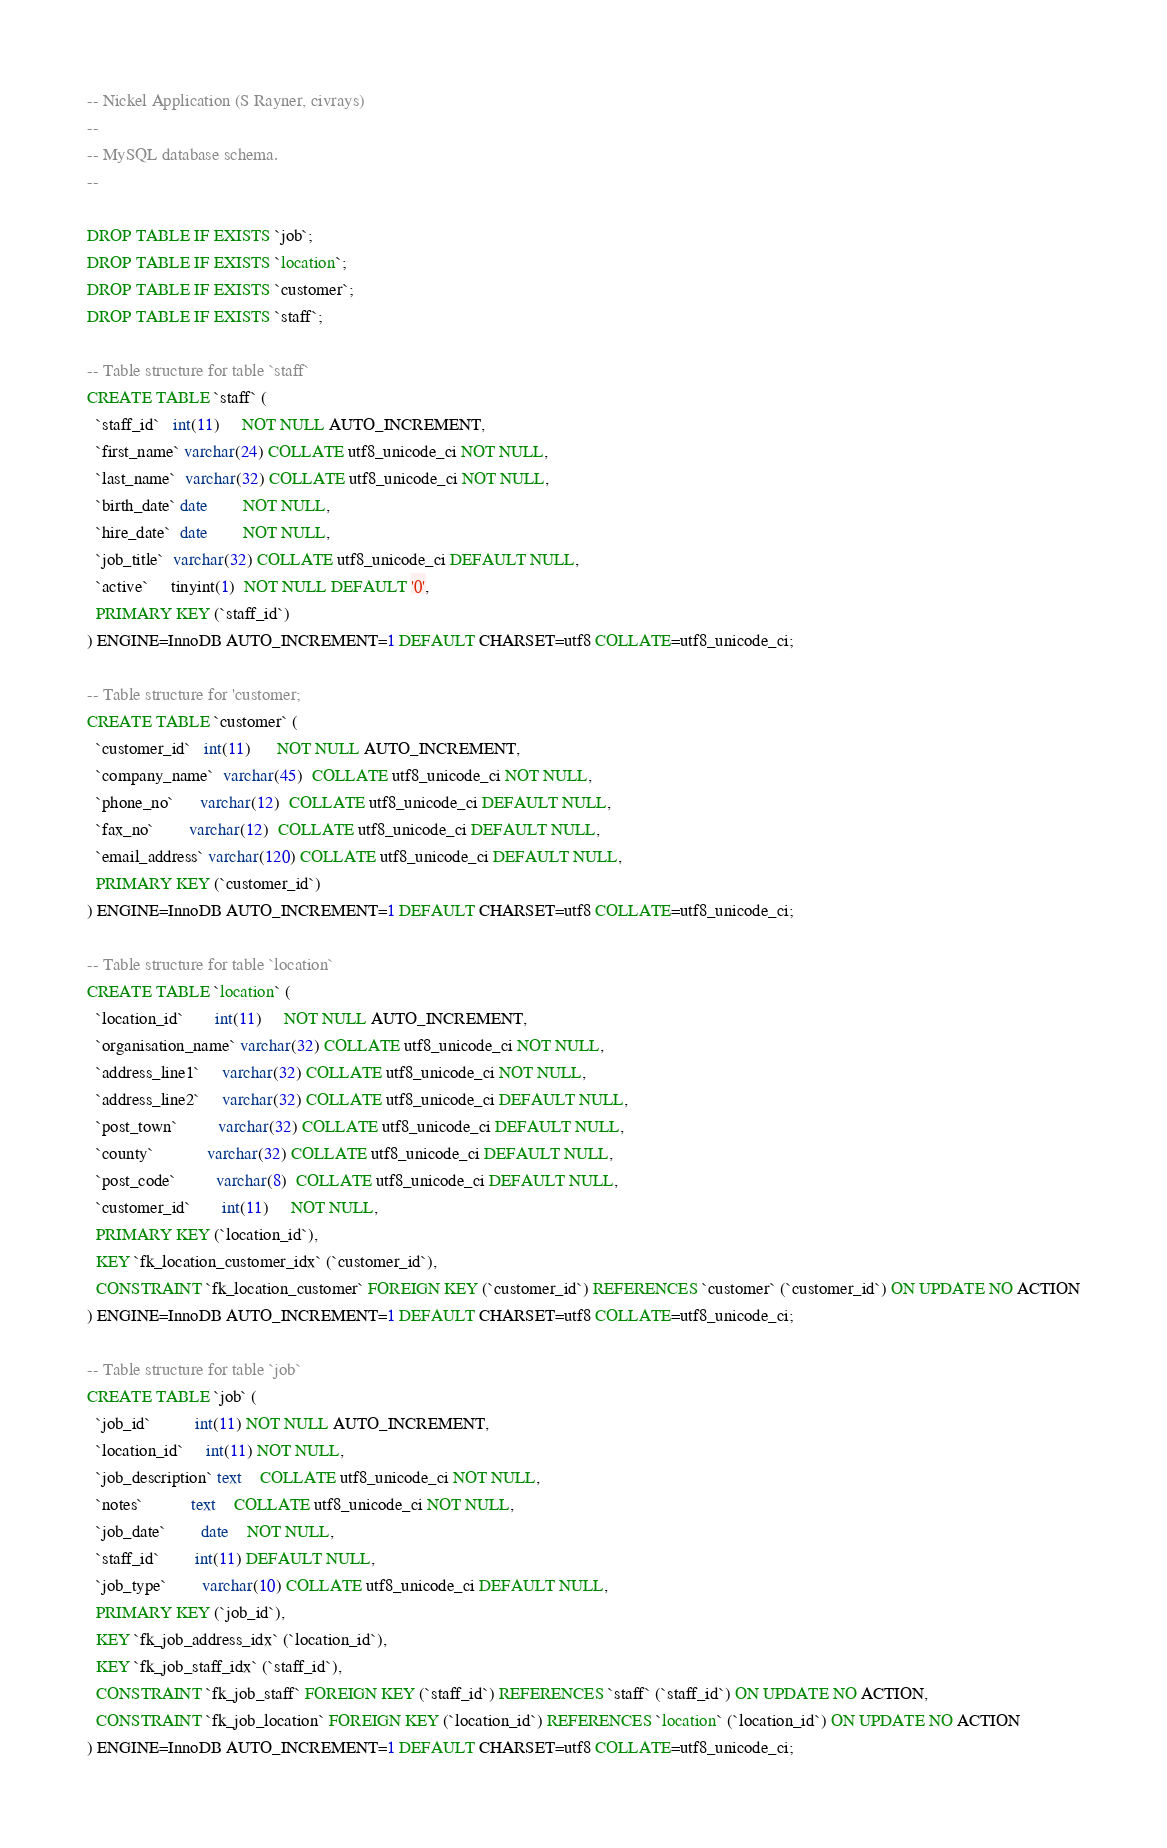Convert code to text. <code><loc_0><loc_0><loc_500><loc_500><_SQL_>-- Nickel Application (S Rayner, civrays)
--
-- MySQL database schema.
--

DROP TABLE IF EXISTS `job`;
DROP TABLE IF EXISTS `location`;
DROP TABLE IF EXISTS `customer`;
DROP TABLE IF EXISTS `staff`;

-- Table structure for table `staff`
CREATE TABLE `staff` (
  `staff_id`   int(11)     NOT NULL AUTO_INCREMENT,
  `first_name` varchar(24) COLLATE utf8_unicode_ci NOT NULL,
  `last_name`  varchar(32) COLLATE utf8_unicode_ci NOT NULL,
  `birth_date` date        NOT NULL,
  `hire_date`  date        NOT NULL,
  `job_title`  varchar(32) COLLATE utf8_unicode_ci DEFAULT NULL,
  `active`     tinyint(1)  NOT NULL DEFAULT '0',
  PRIMARY KEY (`staff_id`)
) ENGINE=InnoDB AUTO_INCREMENT=1 DEFAULT CHARSET=utf8 COLLATE=utf8_unicode_ci;

-- Table structure for 'customer;
CREATE TABLE `customer` (
  `customer_id`   int(11)      NOT NULL AUTO_INCREMENT,
  `company_name`  varchar(45)  COLLATE utf8_unicode_ci NOT NULL,
  `phone_no`      varchar(12)  COLLATE utf8_unicode_ci DEFAULT NULL,
  `fax_no`        varchar(12)  COLLATE utf8_unicode_ci DEFAULT NULL,
  `email_address` varchar(120) COLLATE utf8_unicode_ci DEFAULT NULL,
  PRIMARY KEY (`customer_id`)
) ENGINE=InnoDB AUTO_INCREMENT=1 DEFAULT CHARSET=utf8 COLLATE=utf8_unicode_ci;

-- Table structure for table `location`
CREATE TABLE `location` (
  `location_id`       int(11)     NOT NULL AUTO_INCREMENT,
  `organisation_name` varchar(32) COLLATE utf8_unicode_ci NOT NULL,
  `address_line1`     varchar(32) COLLATE utf8_unicode_ci NOT NULL,
  `address_line2`     varchar(32) COLLATE utf8_unicode_ci DEFAULT NULL,
  `post_town`         varchar(32) COLLATE utf8_unicode_ci DEFAULT NULL,
  `county`            varchar(32) COLLATE utf8_unicode_ci DEFAULT NULL,
  `post_code`         varchar(8)  COLLATE utf8_unicode_ci DEFAULT NULL,
  `customer_id`       int(11)     NOT NULL,
  PRIMARY KEY (`location_id`),
  KEY `fk_location_customer_idx` (`customer_id`),
  CONSTRAINT `fk_location_customer` FOREIGN KEY (`customer_id`) REFERENCES `customer` (`customer_id`) ON UPDATE NO ACTION
) ENGINE=InnoDB AUTO_INCREMENT=1 DEFAULT CHARSET=utf8 COLLATE=utf8_unicode_ci;

-- Table structure for table `job`
CREATE TABLE `job` (
  `job_id`          int(11) NOT NULL AUTO_INCREMENT,
  `location_id`     int(11) NOT NULL,
  `job_description` text    COLLATE utf8_unicode_ci NOT NULL,
  `notes`           text    COLLATE utf8_unicode_ci NOT NULL,
  `job_date`        date    NOT NULL,
  `staff_id`        int(11) DEFAULT NULL,
  `job_type`        varchar(10) COLLATE utf8_unicode_ci DEFAULT NULL,
  PRIMARY KEY (`job_id`),
  KEY `fk_job_address_idx` (`location_id`),
  KEY `fk_job_staff_idx` (`staff_id`),
  CONSTRAINT `fk_job_staff` FOREIGN KEY (`staff_id`) REFERENCES `staff` (`staff_id`) ON UPDATE NO ACTION,
  CONSTRAINT `fk_job_location` FOREIGN KEY (`location_id`) REFERENCES `location` (`location_id`) ON UPDATE NO ACTION
) ENGINE=InnoDB AUTO_INCREMENT=1 DEFAULT CHARSET=utf8 COLLATE=utf8_unicode_ci;</code> 